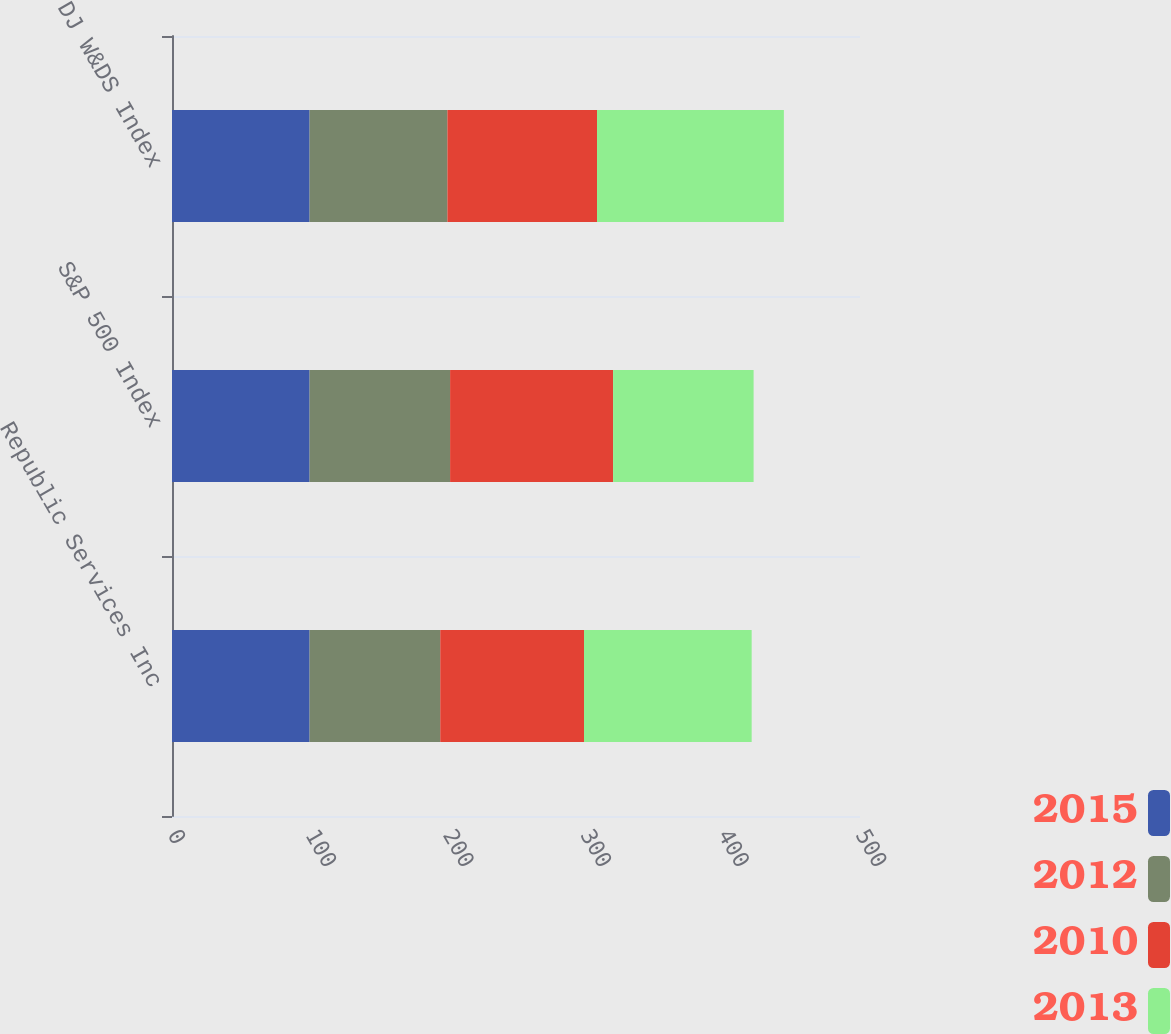Convert chart to OTSL. <chart><loc_0><loc_0><loc_500><loc_500><stacked_bar_chart><ecel><fcel>Republic Services Inc<fcel>S&P 500 Index<fcel>DJ W&DS Index<nl><fcel>2015<fcel>100<fcel>100<fcel>100<nl><fcel>2012<fcel>94.96<fcel>102.11<fcel>100.18<nl><fcel>2010<fcel>104.47<fcel>118.45<fcel>108.7<nl><fcel>2013<fcel>121.84<fcel>102.11<fcel>135.8<nl></chart> 